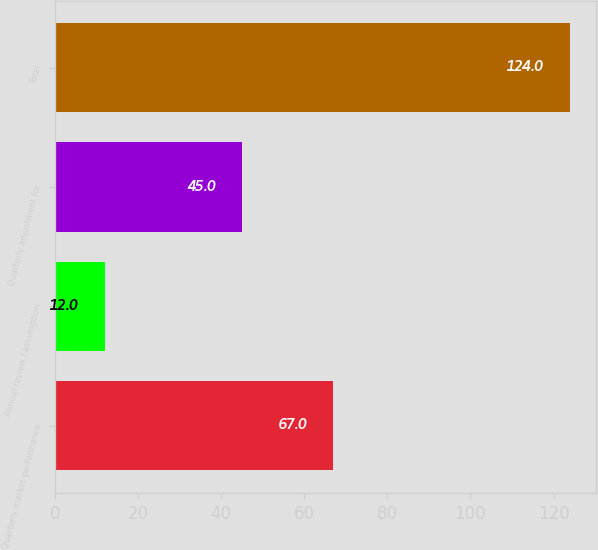Convert chart to OTSL. <chart><loc_0><loc_0><loc_500><loc_500><bar_chart><fcel>Quarterly market performance<fcel>Annual review / assumption<fcel>Quarterly adjustment for<fcel>Total<nl><fcel>67<fcel>12<fcel>45<fcel>124<nl></chart> 